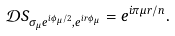<formula> <loc_0><loc_0><loc_500><loc_500>\mathcal { D } S _ { \sigma _ { \mu } e ^ { i \phi _ { \mu } / 2 } , e ^ { i r \phi _ { \mu } } } = e ^ { i \pi \mu r / n } .</formula> 